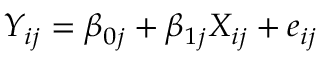<formula> <loc_0><loc_0><loc_500><loc_500>Y _ { i j } = \beta _ { 0 j } + \beta _ { 1 j } X _ { i j } + e _ { i j }</formula> 